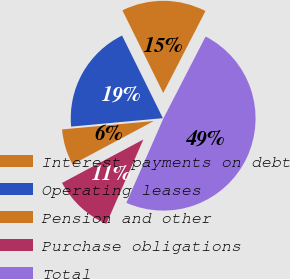Convert chart to OTSL. <chart><loc_0><loc_0><loc_500><loc_500><pie_chart><fcel>Interest payments on debt<fcel>Operating leases<fcel>Pension and other<fcel>Purchase obligations<fcel>Total<nl><fcel>14.88%<fcel>19.15%<fcel>6.35%<fcel>10.61%<fcel>49.01%<nl></chart> 